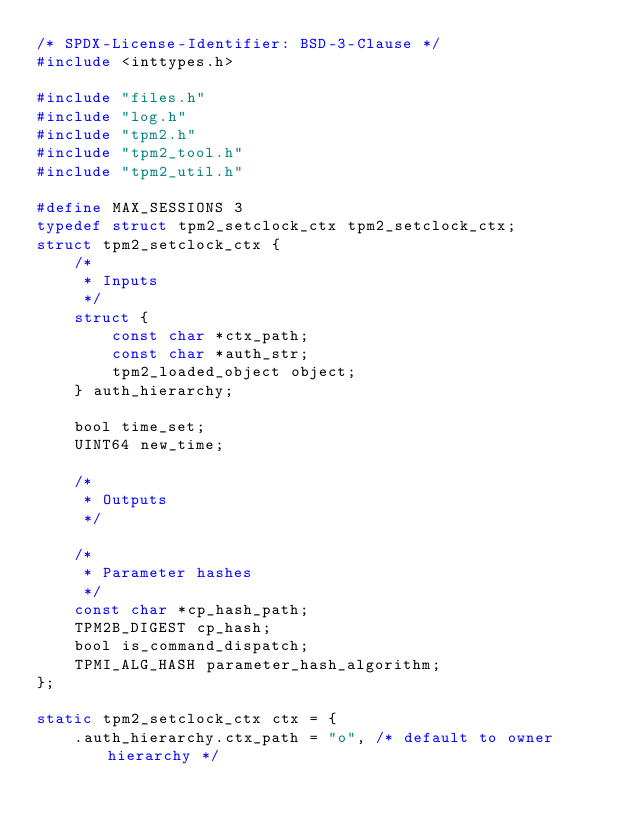Convert code to text. <code><loc_0><loc_0><loc_500><loc_500><_C_>/* SPDX-License-Identifier: BSD-3-Clause */
#include <inttypes.h>

#include "files.h"
#include "log.h"
#include "tpm2.h"
#include "tpm2_tool.h"
#include "tpm2_util.h"

#define MAX_SESSIONS 3
typedef struct tpm2_setclock_ctx tpm2_setclock_ctx;
struct tpm2_setclock_ctx {
    /*
     * Inputs
     */
    struct {
        const char *ctx_path;
        const char *auth_str;
        tpm2_loaded_object object;
    } auth_hierarchy;

    bool time_set;
    UINT64 new_time;

    /*
     * Outputs
     */

    /*
     * Parameter hashes
     */
    const char *cp_hash_path;
    TPM2B_DIGEST cp_hash;
    bool is_command_dispatch;
    TPMI_ALG_HASH parameter_hash_algorithm;
};

static tpm2_setclock_ctx ctx = {
    .auth_hierarchy.ctx_path = "o", /* default to owner hierarchy */</code> 